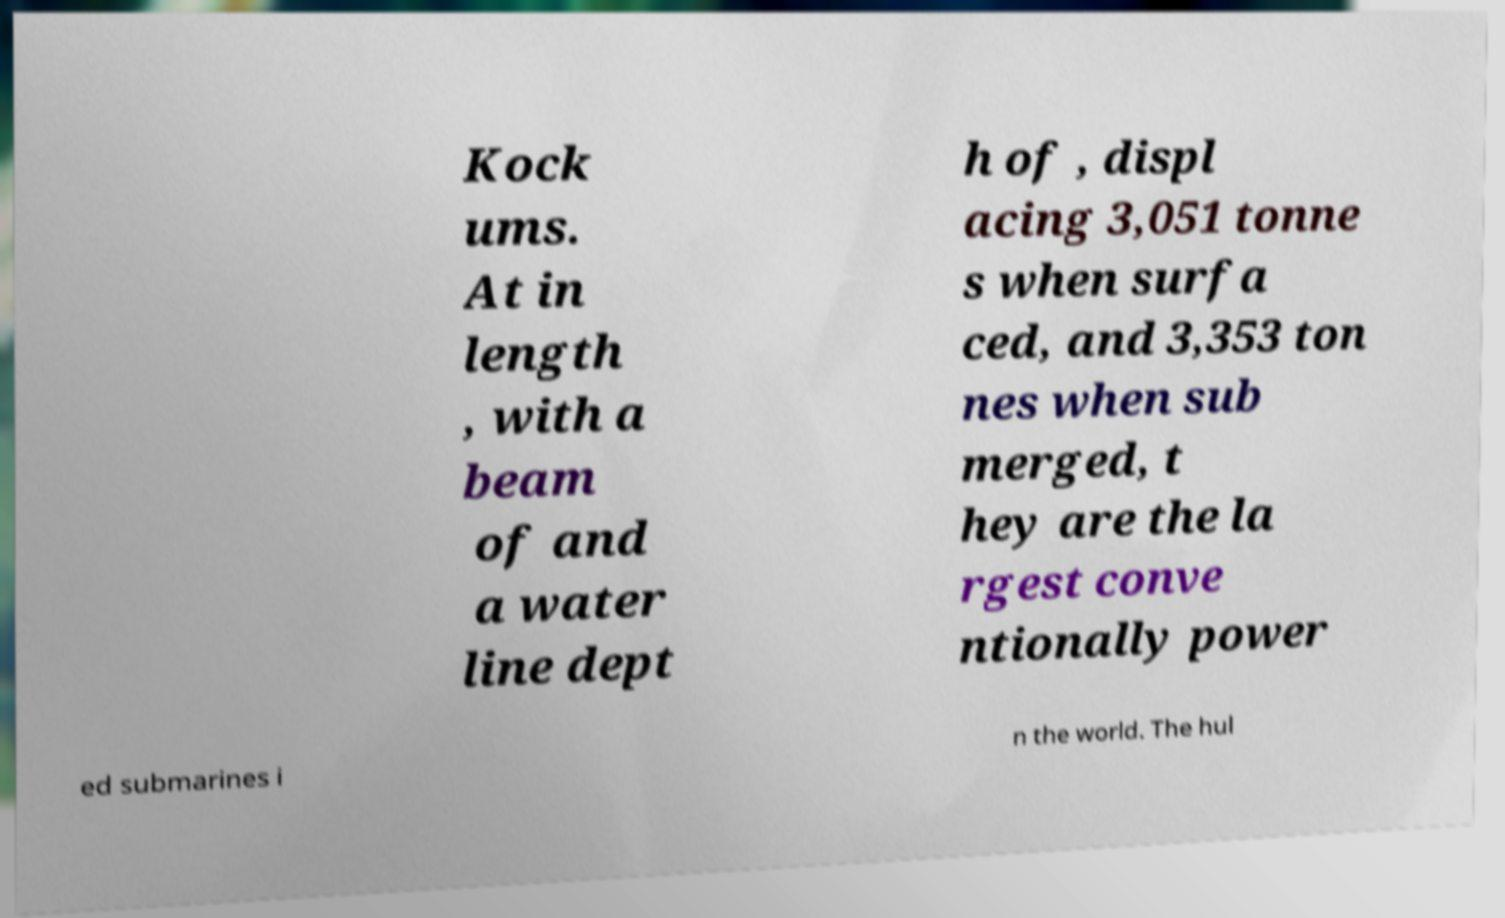Could you extract and type out the text from this image? Kock ums. At in length , with a beam of and a water line dept h of , displ acing 3,051 tonne s when surfa ced, and 3,353 ton nes when sub merged, t hey are the la rgest conve ntionally power ed submarines i n the world. The hul 